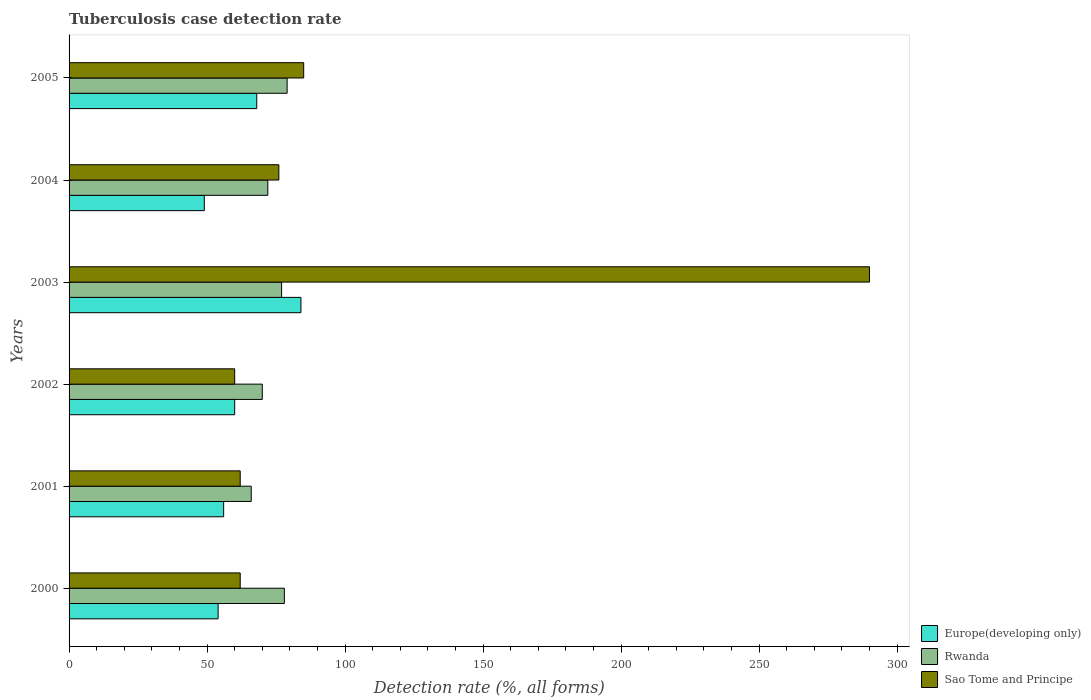How many different coloured bars are there?
Keep it short and to the point. 3. Are the number of bars per tick equal to the number of legend labels?
Ensure brevity in your answer.  Yes. Are the number of bars on each tick of the Y-axis equal?
Offer a terse response. Yes. How many bars are there on the 4th tick from the top?
Ensure brevity in your answer.  3. What is the label of the 2nd group of bars from the top?
Give a very brief answer. 2004. In how many cases, is the number of bars for a given year not equal to the number of legend labels?
Offer a very short reply. 0. What is the tuberculosis case detection rate in in Sao Tome and Principe in 2003?
Offer a terse response. 290. Across all years, what is the maximum tuberculosis case detection rate in in Sao Tome and Principe?
Offer a very short reply. 290. Across all years, what is the minimum tuberculosis case detection rate in in Rwanda?
Your answer should be compact. 66. In which year was the tuberculosis case detection rate in in Europe(developing only) maximum?
Offer a terse response. 2003. In which year was the tuberculosis case detection rate in in Rwanda minimum?
Offer a terse response. 2001. What is the total tuberculosis case detection rate in in Europe(developing only) in the graph?
Offer a very short reply. 371. What is the difference between the tuberculosis case detection rate in in Sao Tome and Principe in 2004 and that in 2005?
Provide a succinct answer. -9. What is the difference between the tuberculosis case detection rate in in Europe(developing only) in 2004 and the tuberculosis case detection rate in in Rwanda in 2001?
Offer a terse response. -17. What is the average tuberculosis case detection rate in in Europe(developing only) per year?
Offer a very short reply. 61.83. In the year 2005, what is the difference between the tuberculosis case detection rate in in Rwanda and tuberculosis case detection rate in in Sao Tome and Principe?
Ensure brevity in your answer.  -6. In how many years, is the tuberculosis case detection rate in in Europe(developing only) greater than 280 %?
Your answer should be compact. 0. What is the ratio of the tuberculosis case detection rate in in Europe(developing only) in 2000 to that in 2002?
Keep it short and to the point. 0.9. Is the tuberculosis case detection rate in in Europe(developing only) in 2001 less than that in 2005?
Your answer should be very brief. Yes. Is the difference between the tuberculosis case detection rate in in Rwanda in 2002 and 2005 greater than the difference between the tuberculosis case detection rate in in Sao Tome and Principe in 2002 and 2005?
Your answer should be compact. Yes. What is the difference between the highest and the second highest tuberculosis case detection rate in in Sao Tome and Principe?
Offer a very short reply. 205. What is the difference between the highest and the lowest tuberculosis case detection rate in in Europe(developing only)?
Your answer should be very brief. 35. Is the sum of the tuberculosis case detection rate in in Europe(developing only) in 2001 and 2003 greater than the maximum tuberculosis case detection rate in in Rwanda across all years?
Ensure brevity in your answer.  Yes. What does the 2nd bar from the top in 2001 represents?
Offer a terse response. Rwanda. What does the 1st bar from the bottom in 2002 represents?
Provide a succinct answer. Europe(developing only). Is it the case that in every year, the sum of the tuberculosis case detection rate in in Europe(developing only) and tuberculosis case detection rate in in Sao Tome and Principe is greater than the tuberculosis case detection rate in in Rwanda?
Your answer should be very brief. Yes. How many bars are there?
Keep it short and to the point. 18. What is the difference between two consecutive major ticks on the X-axis?
Your answer should be very brief. 50. Are the values on the major ticks of X-axis written in scientific E-notation?
Ensure brevity in your answer.  No. Does the graph contain any zero values?
Make the answer very short. No. Does the graph contain grids?
Keep it short and to the point. No. Where does the legend appear in the graph?
Your response must be concise. Bottom right. How are the legend labels stacked?
Offer a very short reply. Vertical. What is the title of the graph?
Provide a succinct answer. Tuberculosis case detection rate. What is the label or title of the X-axis?
Your answer should be compact. Detection rate (%, all forms). What is the label or title of the Y-axis?
Provide a succinct answer. Years. What is the Detection rate (%, all forms) of Rwanda in 2000?
Offer a terse response. 78. What is the Detection rate (%, all forms) in Sao Tome and Principe in 2000?
Your answer should be very brief. 62. What is the Detection rate (%, all forms) in Europe(developing only) in 2002?
Your answer should be compact. 60. What is the Detection rate (%, all forms) in Rwanda in 2002?
Your answer should be compact. 70. What is the Detection rate (%, all forms) of Sao Tome and Principe in 2002?
Give a very brief answer. 60. What is the Detection rate (%, all forms) in Sao Tome and Principe in 2003?
Ensure brevity in your answer.  290. What is the Detection rate (%, all forms) of Europe(developing only) in 2004?
Offer a very short reply. 49. What is the Detection rate (%, all forms) of Rwanda in 2004?
Offer a terse response. 72. What is the Detection rate (%, all forms) in Europe(developing only) in 2005?
Keep it short and to the point. 68. What is the Detection rate (%, all forms) of Rwanda in 2005?
Offer a very short reply. 79. Across all years, what is the maximum Detection rate (%, all forms) of Rwanda?
Ensure brevity in your answer.  79. Across all years, what is the maximum Detection rate (%, all forms) of Sao Tome and Principe?
Your answer should be compact. 290. Across all years, what is the minimum Detection rate (%, all forms) of Rwanda?
Offer a very short reply. 66. What is the total Detection rate (%, all forms) in Europe(developing only) in the graph?
Offer a very short reply. 371. What is the total Detection rate (%, all forms) in Rwanda in the graph?
Provide a short and direct response. 442. What is the total Detection rate (%, all forms) of Sao Tome and Principe in the graph?
Ensure brevity in your answer.  635. What is the difference between the Detection rate (%, all forms) in Rwanda in 2000 and that in 2001?
Ensure brevity in your answer.  12. What is the difference between the Detection rate (%, all forms) of Sao Tome and Principe in 2000 and that in 2001?
Your response must be concise. 0. What is the difference between the Detection rate (%, all forms) of Europe(developing only) in 2000 and that in 2002?
Ensure brevity in your answer.  -6. What is the difference between the Detection rate (%, all forms) in Rwanda in 2000 and that in 2002?
Provide a short and direct response. 8. What is the difference between the Detection rate (%, all forms) in Sao Tome and Principe in 2000 and that in 2002?
Give a very brief answer. 2. What is the difference between the Detection rate (%, all forms) of Sao Tome and Principe in 2000 and that in 2003?
Your answer should be very brief. -228. What is the difference between the Detection rate (%, all forms) in Rwanda in 2000 and that in 2004?
Your answer should be very brief. 6. What is the difference between the Detection rate (%, all forms) in Rwanda in 2000 and that in 2005?
Offer a very short reply. -1. What is the difference between the Detection rate (%, all forms) in Sao Tome and Principe in 2001 and that in 2002?
Give a very brief answer. 2. What is the difference between the Detection rate (%, all forms) of Sao Tome and Principe in 2001 and that in 2003?
Give a very brief answer. -228. What is the difference between the Detection rate (%, all forms) of Sao Tome and Principe in 2001 and that in 2004?
Offer a very short reply. -14. What is the difference between the Detection rate (%, all forms) in Europe(developing only) in 2002 and that in 2003?
Provide a succinct answer. -24. What is the difference between the Detection rate (%, all forms) of Rwanda in 2002 and that in 2003?
Your answer should be compact. -7. What is the difference between the Detection rate (%, all forms) in Sao Tome and Principe in 2002 and that in 2003?
Provide a succinct answer. -230. What is the difference between the Detection rate (%, all forms) of Sao Tome and Principe in 2002 and that in 2004?
Offer a terse response. -16. What is the difference between the Detection rate (%, all forms) of Europe(developing only) in 2002 and that in 2005?
Offer a very short reply. -8. What is the difference between the Detection rate (%, all forms) of Rwanda in 2002 and that in 2005?
Keep it short and to the point. -9. What is the difference between the Detection rate (%, all forms) of Sao Tome and Principe in 2002 and that in 2005?
Provide a short and direct response. -25. What is the difference between the Detection rate (%, all forms) of Europe(developing only) in 2003 and that in 2004?
Keep it short and to the point. 35. What is the difference between the Detection rate (%, all forms) of Rwanda in 2003 and that in 2004?
Give a very brief answer. 5. What is the difference between the Detection rate (%, all forms) in Sao Tome and Principe in 2003 and that in 2004?
Offer a terse response. 214. What is the difference between the Detection rate (%, all forms) in Sao Tome and Principe in 2003 and that in 2005?
Your response must be concise. 205. What is the difference between the Detection rate (%, all forms) of Europe(developing only) in 2000 and the Detection rate (%, all forms) of Rwanda in 2001?
Your answer should be compact. -12. What is the difference between the Detection rate (%, all forms) in Europe(developing only) in 2000 and the Detection rate (%, all forms) in Sao Tome and Principe in 2001?
Your answer should be very brief. -8. What is the difference between the Detection rate (%, all forms) in Rwanda in 2000 and the Detection rate (%, all forms) in Sao Tome and Principe in 2001?
Ensure brevity in your answer.  16. What is the difference between the Detection rate (%, all forms) of Europe(developing only) in 2000 and the Detection rate (%, all forms) of Sao Tome and Principe in 2002?
Your response must be concise. -6. What is the difference between the Detection rate (%, all forms) of Rwanda in 2000 and the Detection rate (%, all forms) of Sao Tome and Principe in 2002?
Offer a very short reply. 18. What is the difference between the Detection rate (%, all forms) in Europe(developing only) in 2000 and the Detection rate (%, all forms) in Sao Tome and Principe in 2003?
Make the answer very short. -236. What is the difference between the Detection rate (%, all forms) of Rwanda in 2000 and the Detection rate (%, all forms) of Sao Tome and Principe in 2003?
Keep it short and to the point. -212. What is the difference between the Detection rate (%, all forms) of Rwanda in 2000 and the Detection rate (%, all forms) of Sao Tome and Principe in 2004?
Your answer should be compact. 2. What is the difference between the Detection rate (%, all forms) of Europe(developing only) in 2000 and the Detection rate (%, all forms) of Rwanda in 2005?
Keep it short and to the point. -25. What is the difference between the Detection rate (%, all forms) of Europe(developing only) in 2000 and the Detection rate (%, all forms) of Sao Tome and Principe in 2005?
Ensure brevity in your answer.  -31. What is the difference between the Detection rate (%, all forms) of Europe(developing only) in 2001 and the Detection rate (%, all forms) of Rwanda in 2002?
Your answer should be very brief. -14. What is the difference between the Detection rate (%, all forms) of Rwanda in 2001 and the Detection rate (%, all forms) of Sao Tome and Principe in 2002?
Give a very brief answer. 6. What is the difference between the Detection rate (%, all forms) in Europe(developing only) in 2001 and the Detection rate (%, all forms) in Sao Tome and Principe in 2003?
Offer a very short reply. -234. What is the difference between the Detection rate (%, all forms) in Rwanda in 2001 and the Detection rate (%, all forms) in Sao Tome and Principe in 2003?
Provide a succinct answer. -224. What is the difference between the Detection rate (%, all forms) of Europe(developing only) in 2001 and the Detection rate (%, all forms) of Rwanda in 2004?
Make the answer very short. -16. What is the difference between the Detection rate (%, all forms) of Europe(developing only) in 2001 and the Detection rate (%, all forms) of Rwanda in 2005?
Your response must be concise. -23. What is the difference between the Detection rate (%, all forms) in Europe(developing only) in 2001 and the Detection rate (%, all forms) in Sao Tome and Principe in 2005?
Make the answer very short. -29. What is the difference between the Detection rate (%, all forms) of Rwanda in 2001 and the Detection rate (%, all forms) of Sao Tome and Principe in 2005?
Your response must be concise. -19. What is the difference between the Detection rate (%, all forms) in Europe(developing only) in 2002 and the Detection rate (%, all forms) in Rwanda in 2003?
Make the answer very short. -17. What is the difference between the Detection rate (%, all forms) in Europe(developing only) in 2002 and the Detection rate (%, all forms) in Sao Tome and Principe in 2003?
Your response must be concise. -230. What is the difference between the Detection rate (%, all forms) of Rwanda in 2002 and the Detection rate (%, all forms) of Sao Tome and Principe in 2003?
Your response must be concise. -220. What is the difference between the Detection rate (%, all forms) in Europe(developing only) in 2002 and the Detection rate (%, all forms) in Sao Tome and Principe in 2004?
Your answer should be very brief. -16. What is the difference between the Detection rate (%, all forms) of Rwanda in 2002 and the Detection rate (%, all forms) of Sao Tome and Principe in 2004?
Make the answer very short. -6. What is the difference between the Detection rate (%, all forms) in Europe(developing only) in 2002 and the Detection rate (%, all forms) in Sao Tome and Principe in 2005?
Provide a short and direct response. -25. What is the difference between the Detection rate (%, all forms) of Europe(developing only) in 2003 and the Detection rate (%, all forms) of Rwanda in 2004?
Give a very brief answer. 12. What is the difference between the Detection rate (%, all forms) of Rwanda in 2003 and the Detection rate (%, all forms) of Sao Tome and Principe in 2005?
Keep it short and to the point. -8. What is the difference between the Detection rate (%, all forms) of Europe(developing only) in 2004 and the Detection rate (%, all forms) of Sao Tome and Principe in 2005?
Provide a succinct answer. -36. What is the difference between the Detection rate (%, all forms) of Rwanda in 2004 and the Detection rate (%, all forms) of Sao Tome and Principe in 2005?
Keep it short and to the point. -13. What is the average Detection rate (%, all forms) of Europe(developing only) per year?
Provide a short and direct response. 61.83. What is the average Detection rate (%, all forms) of Rwanda per year?
Your answer should be compact. 73.67. What is the average Detection rate (%, all forms) in Sao Tome and Principe per year?
Ensure brevity in your answer.  105.83. In the year 2000, what is the difference between the Detection rate (%, all forms) of Rwanda and Detection rate (%, all forms) of Sao Tome and Principe?
Provide a short and direct response. 16. In the year 2001, what is the difference between the Detection rate (%, all forms) of Europe(developing only) and Detection rate (%, all forms) of Rwanda?
Provide a succinct answer. -10. In the year 2002, what is the difference between the Detection rate (%, all forms) in Europe(developing only) and Detection rate (%, all forms) in Sao Tome and Principe?
Your answer should be compact. 0. In the year 2003, what is the difference between the Detection rate (%, all forms) of Europe(developing only) and Detection rate (%, all forms) of Rwanda?
Offer a terse response. 7. In the year 2003, what is the difference between the Detection rate (%, all forms) of Europe(developing only) and Detection rate (%, all forms) of Sao Tome and Principe?
Provide a succinct answer. -206. In the year 2003, what is the difference between the Detection rate (%, all forms) in Rwanda and Detection rate (%, all forms) in Sao Tome and Principe?
Offer a terse response. -213. In the year 2004, what is the difference between the Detection rate (%, all forms) in Rwanda and Detection rate (%, all forms) in Sao Tome and Principe?
Offer a very short reply. -4. In the year 2005, what is the difference between the Detection rate (%, all forms) of Europe(developing only) and Detection rate (%, all forms) of Sao Tome and Principe?
Provide a succinct answer. -17. In the year 2005, what is the difference between the Detection rate (%, all forms) in Rwanda and Detection rate (%, all forms) in Sao Tome and Principe?
Give a very brief answer. -6. What is the ratio of the Detection rate (%, all forms) in Europe(developing only) in 2000 to that in 2001?
Provide a short and direct response. 0.96. What is the ratio of the Detection rate (%, all forms) in Rwanda in 2000 to that in 2001?
Give a very brief answer. 1.18. What is the ratio of the Detection rate (%, all forms) of Europe(developing only) in 2000 to that in 2002?
Give a very brief answer. 0.9. What is the ratio of the Detection rate (%, all forms) in Rwanda in 2000 to that in 2002?
Your response must be concise. 1.11. What is the ratio of the Detection rate (%, all forms) in Sao Tome and Principe in 2000 to that in 2002?
Give a very brief answer. 1.03. What is the ratio of the Detection rate (%, all forms) of Europe(developing only) in 2000 to that in 2003?
Ensure brevity in your answer.  0.64. What is the ratio of the Detection rate (%, all forms) in Sao Tome and Principe in 2000 to that in 2003?
Provide a short and direct response. 0.21. What is the ratio of the Detection rate (%, all forms) of Europe(developing only) in 2000 to that in 2004?
Offer a terse response. 1.1. What is the ratio of the Detection rate (%, all forms) in Sao Tome and Principe in 2000 to that in 2004?
Provide a short and direct response. 0.82. What is the ratio of the Detection rate (%, all forms) in Europe(developing only) in 2000 to that in 2005?
Your answer should be very brief. 0.79. What is the ratio of the Detection rate (%, all forms) in Rwanda in 2000 to that in 2005?
Provide a succinct answer. 0.99. What is the ratio of the Detection rate (%, all forms) in Sao Tome and Principe in 2000 to that in 2005?
Offer a terse response. 0.73. What is the ratio of the Detection rate (%, all forms) of Europe(developing only) in 2001 to that in 2002?
Give a very brief answer. 0.93. What is the ratio of the Detection rate (%, all forms) in Rwanda in 2001 to that in 2002?
Offer a very short reply. 0.94. What is the ratio of the Detection rate (%, all forms) in Sao Tome and Principe in 2001 to that in 2002?
Keep it short and to the point. 1.03. What is the ratio of the Detection rate (%, all forms) of Europe(developing only) in 2001 to that in 2003?
Give a very brief answer. 0.67. What is the ratio of the Detection rate (%, all forms) of Sao Tome and Principe in 2001 to that in 2003?
Ensure brevity in your answer.  0.21. What is the ratio of the Detection rate (%, all forms) in Europe(developing only) in 2001 to that in 2004?
Provide a succinct answer. 1.14. What is the ratio of the Detection rate (%, all forms) in Sao Tome and Principe in 2001 to that in 2004?
Your response must be concise. 0.82. What is the ratio of the Detection rate (%, all forms) of Europe(developing only) in 2001 to that in 2005?
Your answer should be compact. 0.82. What is the ratio of the Detection rate (%, all forms) in Rwanda in 2001 to that in 2005?
Your answer should be very brief. 0.84. What is the ratio of the Detection rate (%, all forms) of Sao Tome and Principe in 2001 to that in 2005?
Provide a succinct answer. 0.73. What is the ratio of the Detection rate (%, all forms) in Europe(developing only) in 2002 to that in 2003?
Make the answer very short. 0.71. What is the ratio of the Detection rate (%, all forms) of Rwanda in 2002 to that in 2003?
Offer a very short reply. 0.91. What is the ratio of the Detection rate (%, all forms) of Sao Tome and Principe in 2002 to that in 2003?
Offer a very short reply. 0.21. What is the ratio of the Detection rate (%, all forms) of Europe(developing only) in 2002 to that in 2004?
Your response must be concise. 1.22. What is the ratio of the Detection rate (%, all forms) in Rwanda in 2002 to that in 2004?
Your response must be concise. 0.97. What is the ratio of the Detection rate (%, all forms) of Sao Tome and Principe in 2002 to that in 2004?
Ensure brevity in your answer.  0.79. What is the ratio of the Detection rate (%, all forms) in Europe(developing only) in 2002 to that in 2005?
Provide a succinct answer. 0.88. What is the ratio of the Detection rate (%, all forms) of Rwanda in 2002 to that in 2005?
Your response must be concise. 0.89. What is the ratio of the Detection rate (%, all forms) of Sao Tome and Principe in 2002 to that in 2005?
Provide a succinct answer. 0.71. What is the ratio of the Detection rate (%, all forms) of Europe(developing only) in 2003 to that in 2004?
Provide a succinct answer. 1.71. What is the ratio of the Detection rate (%, all forms) in Rwanda in 2003 to that in 2004?
Offer a very short reply. 1.07. What is the ratio of the Detection rate (%, all forms) of Sao Tome and Principe in 2003 to that in 2004?
Keep it short and to the point. 3.82. What is the ratio of the Detection rate (%, all forms) in Europe(developing only) in 2003 to that in 2005?
Provide a short and direct response. 1.24. What is the ratio of the Detection rate (%, all forms) of Rwanda in 2003 to that in 2005?
Provide a short and direct response. 0.97. What is the ratio of the Detection rate (%, all forms) in Sao Tome and Principe in 2003 to that in 2005?
Provide a short and direct response. 3.41. What is the ratio of the Detection rate (%, all forms) in Europe(developing only) in 2004 to that in 2005?
Provide a short and direct response. 0.72. What is the ratio of the Detection rate (%, all forms) in Rwanda in 2004 to that in 2005?
Your answer should be very brief. 0.91. What is the ratio of the Detection rate (%, all forms) in Sao Tome and Principe in 2004 to that in 2005?
Offer a terse response. 0.89. What is the difference between the highest and the second highest Detection rate (%, all forms) in Rwanda?
Your answer should be very brief. 1. What is the difference between the highest and the second highest Detection rate (%, all forms) of Sao Tome and Principe?
Your answer should be very brief. 205. What is the difference between the highest and the lowest Detection rate (%, all forms) of Europe(developing only)?
Your response must be concise. 35. What is the difference between the highest and the lowest Detection rate (%, all forms) of Sao Tome and Principe?
Ensure brevity in your answer.  230. 